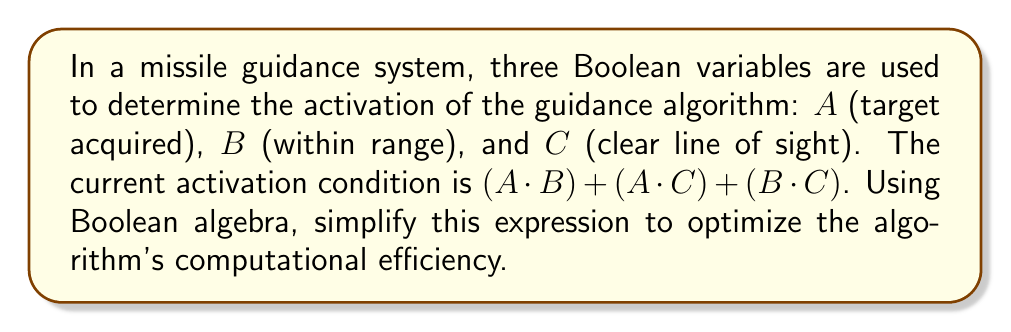Solve this math problem. Let's simplify the expression $(A \cdot B) + (A \cdot C) + (B \cdot C)$ step by step:

1) First, we can apply the distributive law to factor out $A$:
   $$(A \cdot B) + (A \cdot C) + (B \cdot C) = A(B + C) + (B \cdot C)$$

2) Now, we can apply the absorption law. The absorption law states that $X + (X \cdot Y) = X$. In our case, $X = A(B + C)$ and $Y = B \cdot C$:
   $$A(B + C) + (B \cdot C) = A(B + C) + (A \cdot B \cdot C) + (B \cdot C)$$

3) We can now distribute $A$ over $(B + C)$:
   $$(A \cdot B) + (A \cdot C) + (A \cdot B \cdot C) + (B \cdot C)$$

4) The term $(A \cdot B \cdot C)$ is redundant because it's already included in $(A \cdot B)$ and $(A \cdot C)$, so we can remove it:
   $$(A \cdot B) + (A \cdot C) + (B \cdot C)$$

5) This is our original expression, which means it was already in its simplest form.

Therefore, the expression $(A \cdot B) + (A \cdot C) + (B \cdot C)$ is already optimized and cannot be simplified further using Boolean algebra.
Answer: $(A \cdot B) + (A \cdot C) + (B \cdot C)$ 